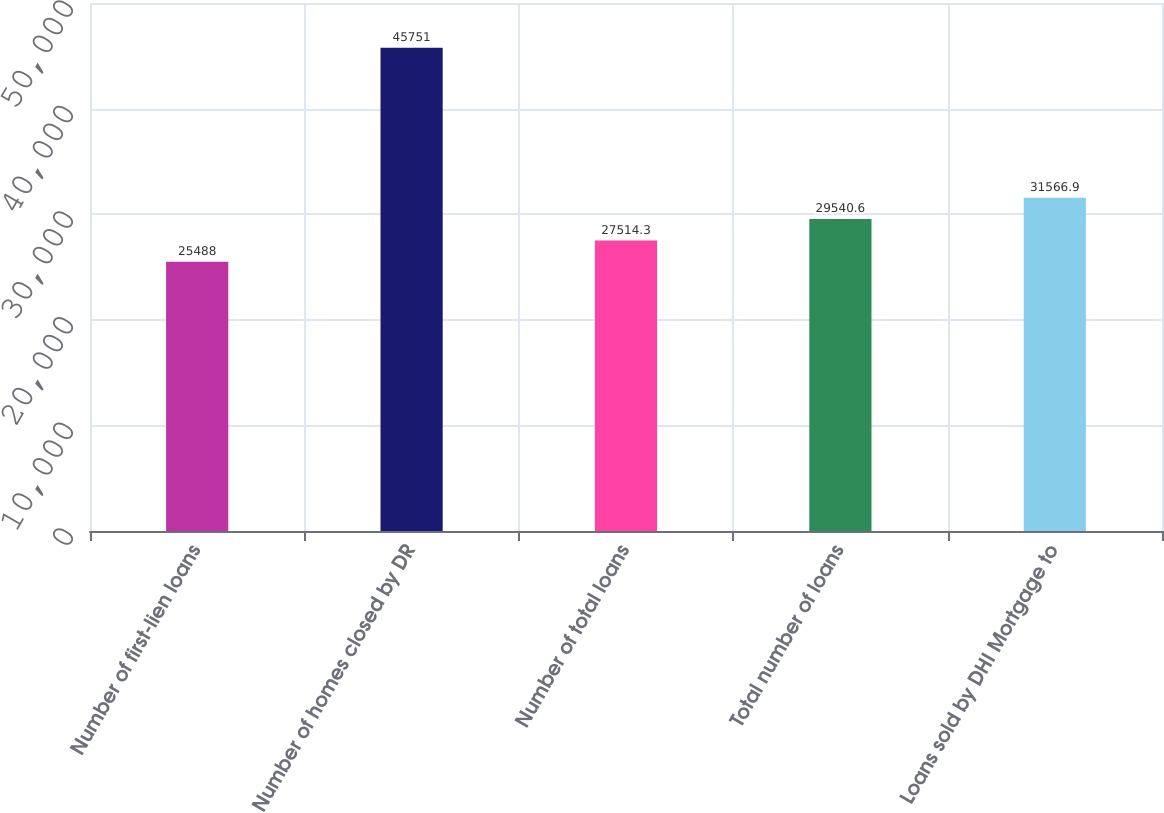Convert chart. <chart><loc_0><loc_0><loc_500><loc_500><bar_chart><fcel>Number of first-lien loans<fcel>Number of homes closed by DR<fcel>Number of total loans<fcel>Total number of loans<fcel>Loans sold by DHI Mortgage to<nl><fcel>25488<fcel>45751<fcel>27514.3<fcel>29540.6<fcel>31566.9<nl></chart> 